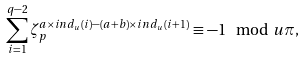<formula> <loc_0><loc_0><loc_500><loc_500>\sum _ { i = 1 } ^ { q - 2 } \zeta _ { p } ^ { a \times i n d _ { u } ( i ) - ( a + b ) \times i n d _ { u } ( i + 1 ) } \equiv - 1 \mod u \pi ,</formula> 